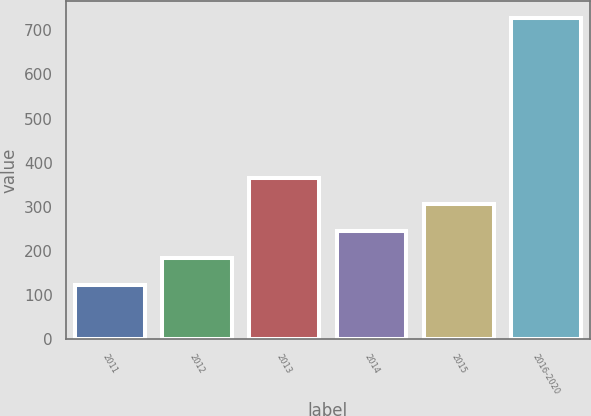Convert chart to OTSL. <chart><loc_0><loc_0><loc_500><loc_500><bar_chart><fcel>2011<fcel>2012<fcel>2013<fcel>2014<fcel>2015<fcel>2016-2020<nl><fcel>124<fcel>184.5<fcel>366<fcel>245<fcel>305.5<fcel>729<nl></chart> 